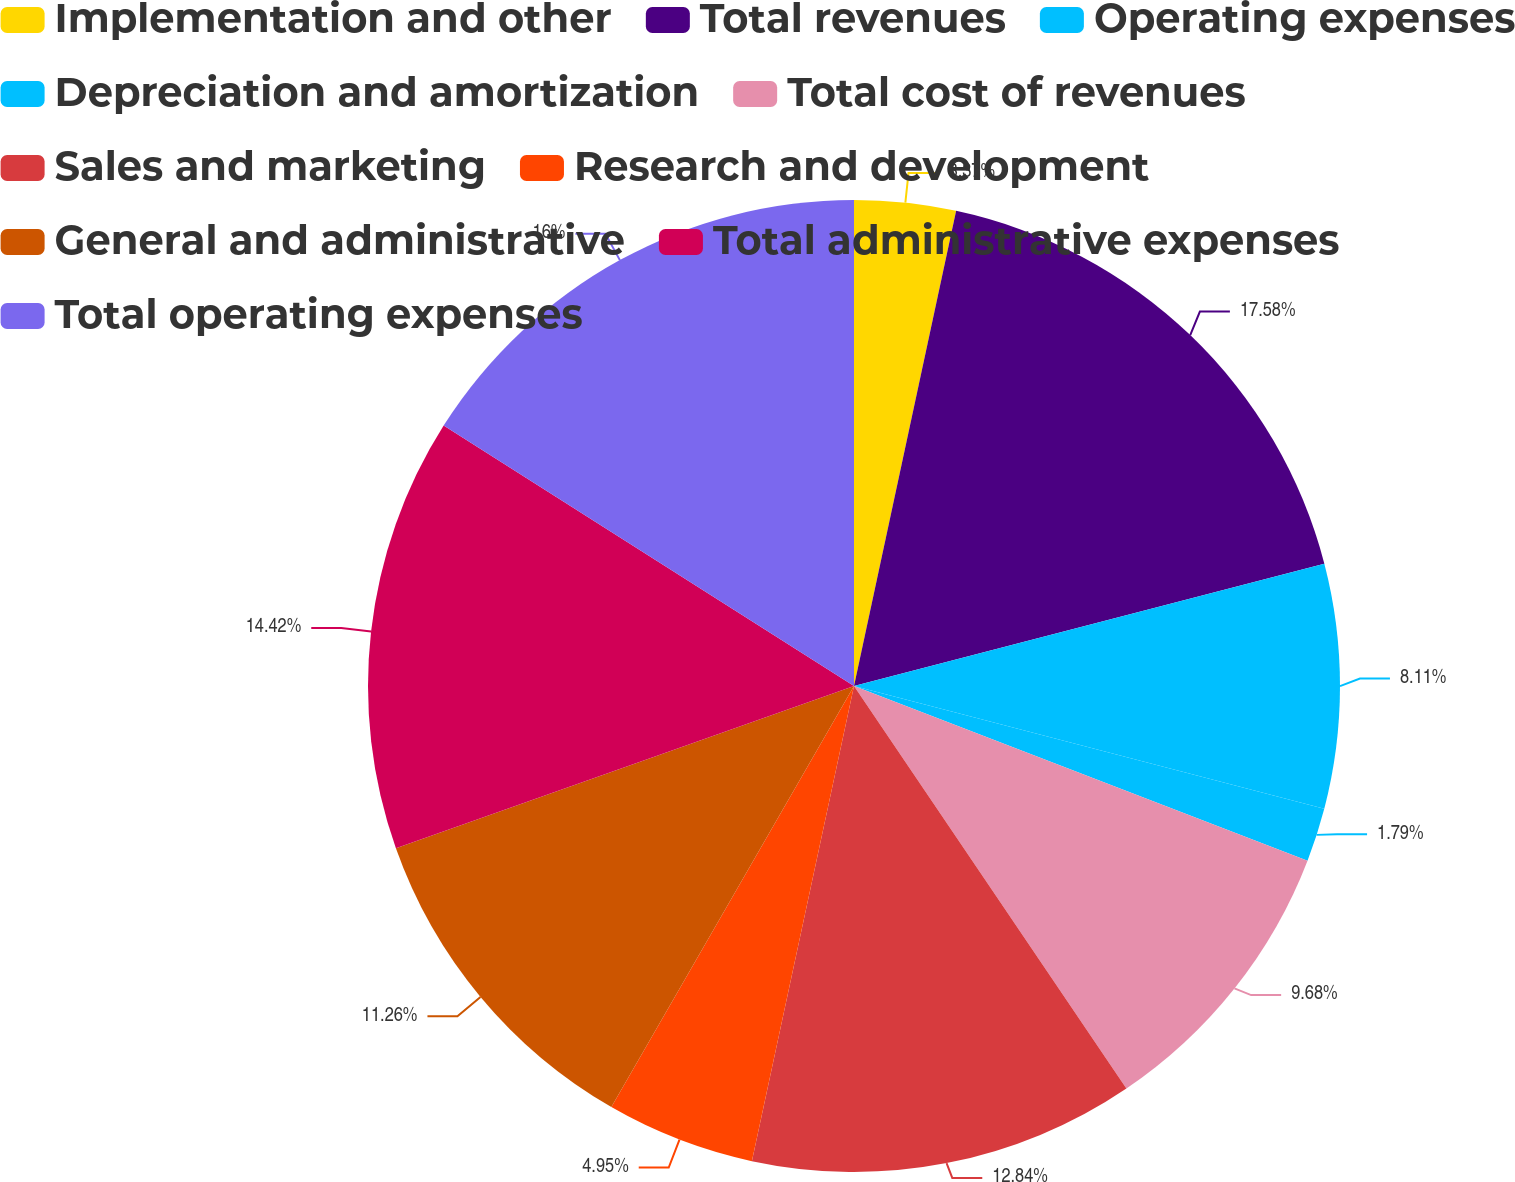Convert chart. <chart><loc_0><loc_0><loc_500><loc_500><pie_chart><fcel>Implementation and other<fcel>Total revenues<fcel>Operating expenses<fcel>Depreciation and amortization<fcel>Total cost of revenues<fcel>Sales and marketing<fcel>Research and development<fcel>General and administrative<fcel>Total administrative expenses<fcel>Total operating expenses<nl><fcel>3.37%<fcel>17.58%<fcel>8.11%<fcel>1.79%<fcel>9.68%<fcel>12.84%<fcel>4.95%<fcel>11.26%<fcel>14.42%<fcel>16.0%<nl></chart> 